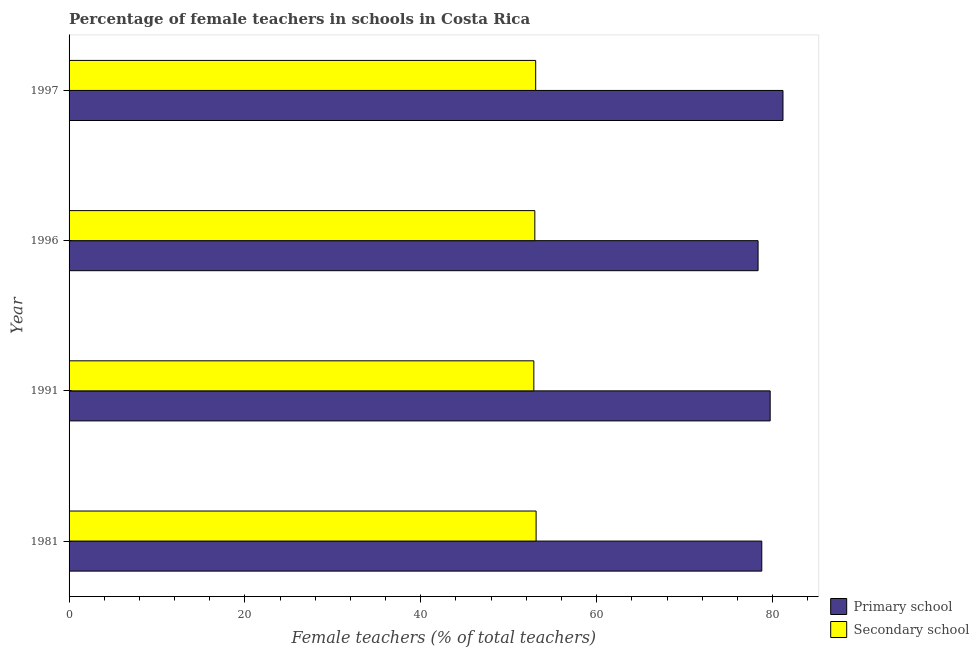How many different coloured bars are there?
Your answer should be compact. 2. Are the number of bars on each tick of the Y-axis equal?
Offer a very short reply. Yes. How many bars are there on the 2nd tick from the top?
Offer a very short reply. 2. How many bars are there on the 3rd tick from the bottom?
Provide a succinct answer. 2. In how many cases, is the number of bars for a given year not equal to the number of legend labels?
Provide a succinct answer. 0. What is the percentage of female teachers in primary schools in 1996?
Offer a terse response. 78.36. Across all years, what is the maximum percentage of female teachers in secondary schools?
Ensure brevity in your answer.  53.11. Across all years, what is the minimum percentage of female teachers in secondary schools?
Ensure brevity in your answer.  52.86. What is the total percentage of female teachers in primary schools in the graph?
Ensure brevity in your answer.  318.06. What is the difference between the percentage of female teachers in primary schools in 1981 and that in 1997?
Give a very brief answer. -2.41. What is the difference between the percentage of female teachers in secondary schools in 1991 and the percentage of female teachers in primary schools in 1997?
Make the answer very short. -28.33. What is the average percentage of female teachers in primary schools per year?
Keep it short and to the point. 79.52. In the year 1997, what is the difference between the percentage of female teachers in primary schools and percentage of female teachers in secondary schools?
Offer a very short reply. 28.12. In how many years, is the percentage of female teachers in secondary schools greater than 8 %?
Offer a terse response. 4. What is the difference between the highest and the second highest percentage of female teachers in primary schools?
Your answer should be compact. 1.46. What is the difference between the highest and the lowest percentage of female teachers in secondary schools?
Ensure brevity in your answer.  0.26. What does the 2nd bar from the top in 1997 represents?
Provide a succinct answer. Primary school. What does the 1st bar from the bottom in 1996 represents?
Make the answer very short. Primary school. How many bars are there?
Provide a succinct answer. 8. Are all the bars in the graph horizontal?
Your answer should be compact. Yes. How many years are there in the graph?
Keep it short and to the point. 4. Are the values on the major ticks of X-axis written in scientific E-notation?
Make the answer very short. No. Where does the legend appear in the graph?
Keep it short and to the point. Bottom right. What is the title of the graph?
Your answer should be very brief. Percentage of female teachers in schools in Costa Rica. What is the label or title of the X-axis?
Keep it short and to the point. Female teachers (% of total teachers). What is the label or title of the Y-axis?
Provide a succinct answer. Year. What is the Female teachers (% of total teachers) of Primary school in 1981?
Give a very brief answer. 78.78. What is the Female teachers (% of total teachers) of Secondary school in 1981?
Ensure brevity in your answer.  53.11. What is the Female teachers (% of total teachers) of Primary school in 1991?
Keep it short and to the point. 79.73. What is the Female teachers (% of total teachers) of Secondary school in 1991?
Your answer should be compact. 52.86. What is the Female teachers (% of total teachers) of Primary school in 1996?
Your answer should be very brief. 78.36. What is the Female teachers (% of total teachers) in Secondary school in 1996?
Your answer should be compact. 52.97. What is the Female teachers (% of total teachers) in Primary school in 1997?
Your answer should be compact. 81.19. What is the Female teachers (% of total teachers) of Secondary school in 1997?
Provide a succinct answer. 53.07. Across all years, what is the maximum Female teachers (% of total teachers) of Primary school?
Your response must be concise. 81.19. Across all years, what is the maximum Female teachers (% of total teachers) of Secondary school?
Provide a short and direct response. 53.11. Across all years, what is the minimum Female teachers (% of total teachers) in Primary school?
Keep it short and to the point. 78.36. Across all years, what is the minimum Female teachers (% of total teachers) of Secondary school?
Your answer should be very brief. 52.86. What is the total Female teachers (% of total teachers) of Primary school in the graph?
Provide a short and direct response. 318.06. What is the total Female teachers (% of total teachers) of Secondary school in the graph?
Offer a terse response. 212.01. What is the difference between the Female teachers (% of total teachers) of Primary school in 1981 and that in 1991?
Your answer should be very brief. -0.95. What is the difference between the Female teachers (% of total teachers) of Secondary school in 1981 and that in 1991?
Give a very brief answer. 0.26. What is the difference between the Female teachers (% of total teachers) of Primary school in 1981 and that in 1996?
Provide a succinct answer. 0.42. What is the difference between the Female teachers (% of total teachers) in Secondary school in 1981 and that in 1996?
Your answer should be compact. 0.15. What is the difference between the Female teachers (% of total teachers) in Primary school in 1981 and that in 1997?
Your response must be concise. -2.41. What is the difference between the Female teachers (% of total teachers) in Secondary school in 1981 and that in 1997?
Keep it short and to the point. 0.05. What is the difference between the Female teachers (% of total teachers) of Primary school in 1991 and that in 1996?
Offer a terse response. 1.38. What is the difference between the Female teachers (% of total teachers) of Secondary school in 1991 and that in 1996?
Your answer should be compact. -0.11. What is the difference between the Female teachers (% of total teachers) in Primary school in 1991 and that in 1997?
Offer a very short reply. -1.46. What is the difference between the Female teachers (% of total teachers) of Secondary school in 1991 and that in 1997?
Your answer should be compact. -0.21. What is the difference between the Female teachers (% of total teachers) in Primary school in 1996 and that in 1997?
Keep it short and to the point. -2.83. What is the difference between the Female teachers (% of total teachers) of Secondary school in 1996 and that in 1997?
Ensure brevity in your answer.  -0.1. What is the difference between the Female teachers (% of total teachers) in Primary school in 1981 and the Female teachers (% of total teachers) in Secondary school in 1991?
Offer a terse response. 25.92. What is the difference between the Female teachers (% of total teachers) of Primary school in 1981 and the Female teachers (% of total teachers) of Secondary school in 1996?
Provide a succinct answer. 25.81. What is the difference between the Female teachers (% of total teachers) in Primary school in 1981 and the Female teachers (% of total teachers) in Secondary school in 1997?
Provide a short and direct response. 25.71. What is the difference between the Female teachers (% of total teachers) in Primary school in 1991 and the Female teachers (% of total teachers) in Secondary school in 1996?
Offer a very short reply. 26.77. What is the difference between the Female teachers (% of total teachers) of Primary school in 1991 and the Female teachers (% of total teachers) of Secondary school in 1997?
Make the answer very short. 26.67. What is the difference between the Female teachers (% of total teachers) in Primary school in 1996 and the Female teachers (% of total teachers) in Secondary school in 1997?
Offer a very short reply. 25.29. What is the average Female teachers (% of total teachers) of Primary school per year?
Keep it short and to the point. 79.52. What is the average Female teachers (% of total teachers) of Secondary school per year?
Your response must be concise. 53. In the year 1981, what is the difference between the Female teachers (% of total teachers) of Primary school and Female teachers (% of total teachers) of Secondary school?
Your answer should be very brief. 25.67. In the year 1991, what is the difference between the Female teachers (% of total teachers) in Primary school and Female teachers (% of total teachers) in Secondary school?
Make the answer very short. 26.88. In the year 1996, what is the difference between the Female teachers (% of total teachers) in Primary school and Female teachers (% of total teachers) in Secondary school?
Offer a terse response. 25.39. In the year 1997, what is the difference between the Female teachers (% of total teachers) in Primary school and Female teachers (% of total teachers) in Secondary school?
Give a very brief answer. 28.12. What is the ratio of the Female teachers (% of total teachers) in Primary school in 1981 to that in 1996?
Your response must be concise. 1.01. What is the ratio of the Female teachers (% of total teachers) of Primary school in 1981 to that in 1997?
Ensure brevity in your answer.  0.97. What is the ratio of the Female teachers (% of total teachers) of Primary school in 1991 to that in 1996?
Offer a terse response. 1.02. What is the ratio of the Female teachers (% of total teachers) of Primary school in 1991 to that in 1997?
Provide a succinct answer. 0.98. What is the ratio of the Female teachers (% of total teachers) in Primary school in 1996 to that in 1997?
Your answer should be very brief. 0.97. What is the ratio of the Female teachers (% of total teachers) in Secondary school in 1996 to that in 1997?
Offer a terse response. 1. What is the difference between the highest and the second highest Female teachers (% of total teachers) in Primary school?
Your answer should be compact. 1.46. What is the difference between the highest and the second highest Female teachers (% of total teachers) of Secondary school?
Provide a succinct answer. 0.05. What is the difference between the highest and the lowest Female teachers (% of total teachers) in Primary school?
Offer a very short reply. 2.83. What is the difference between the highest and the lowest Female teachers (% of total teachers) of Secondary school?
Provide a succinct answer. 0.26. 